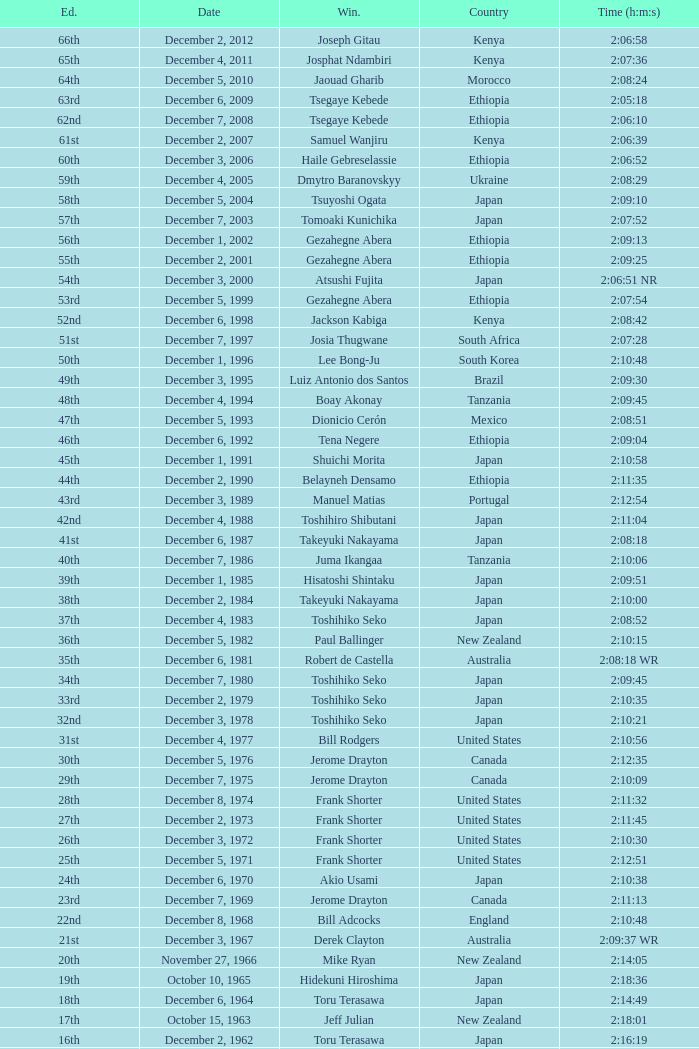What was the nationality of the winner on December 8, 1968? England. 